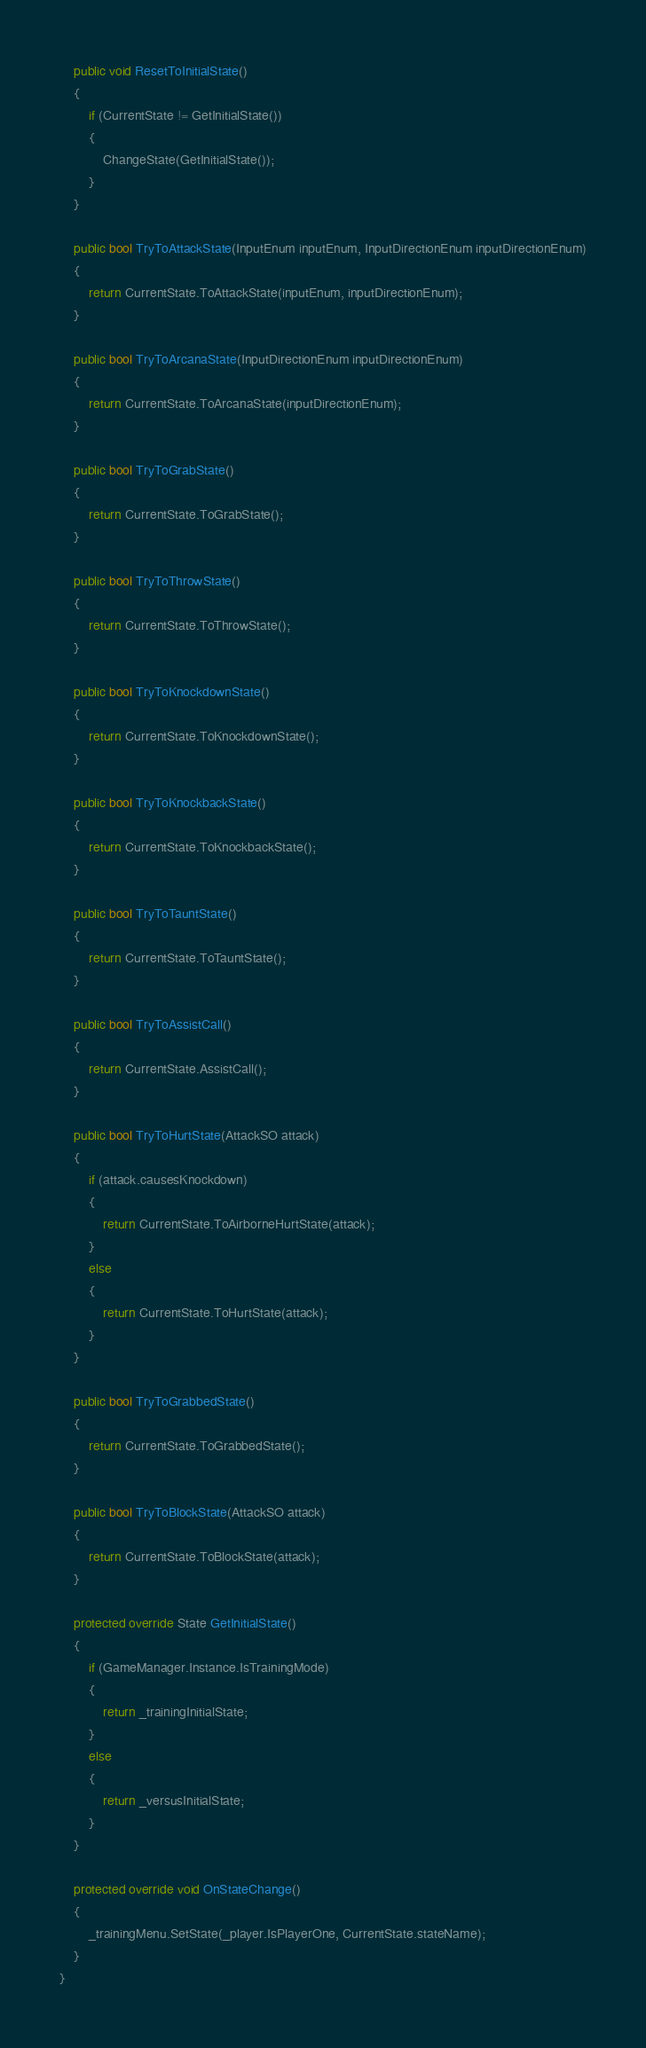<code> <loc_0><loc_0><loc_500><loc_500><_C#_>	public void ResetToInitialState()
	{
		if (CurrentState != GetInitialState())
		{
			ChangeState(GetInitialState());
		}
	}

	public bool TryToAttackState(InputEnum inputEnum, InputDirectionEnum inputDirectionEnum)
	{
		return CurrentState.ToAttackState(inputEnum, inputDirectionEnum);
	}

	public bool TryToArcanaState(InputDirectionEnum inputDirectionEnum)
	{
		return CurrentState.ToArcanaState(inputDirectionEnum);
	}

	public bool TryToGrabState()
	{
		return CurrentState.ToGrabState();
	}

	public bool TryToThrowState()
	{
		return CurrentState.ToThrowState();
	}

	public bool TryToKnockdownState()
	{
		return CurrentState.ToKnockdownState();
	}

	public bool TryToKnockbackState()
	{
		return CurrentState.ToKnockbackState();
	}

	public bool TryToTauntState()
	{
		return CurrentState.ToTauntState();
	}

	public bool TryToAssistCall()
	{
		return CurrentState.AssistCall();
	}

	public bool TryToHurtState(AttackSO attack)
	{
		if (attack.causesKnockdown)
		{
			return CurrentState.ToAirborneHurtState(attack);
		}
		else
		{
			return CurrentState.ToHurtState(attack);
		}
	}

	public bool TryToGrabbedState()
	{
		return CurrentState.ToGrabbedState();
	}

	public bool TryToBlockState(AttackSO attack)
	{
		return CurrentState.ToBlockState(attack);
	}

	protected override State GetInitialState()
	{
		if (GameManager.Instance.IsTrainingMode)
		{
			return _trainingInitialState;
		}
		else
		{
			return _versusInitialState;
		}
	}

	protected override void OnStateChange()
	{
		_trainingMenu.SetState(_player.IsPlayerOne, CurrentState.stateName);
	}
}
</code> 